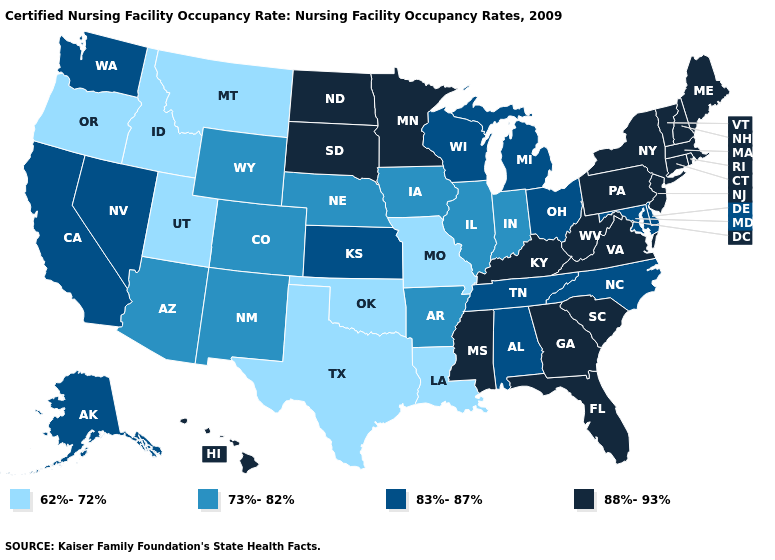Is the legend a continuous bar?
Answer briefly. No. Which states hav the highest value in the South?
Give a very brief answer. Florida, Georgia, Kentucky, Mississippi, South Carolina, Virginia, West Virginia. What is the highest value in the South ?
Answer briefly. 88%-93%. Does New Hampshire have the lowest value in the USA?
Quick response, please. No. What is the value of Missouri?
Be succinct. 62%-72%. Name the states that have a value in the range 83%-87%?
Answer briefly. Alabama, Alaska, California, Delaware, Kansas, Maryland, Michigan, Nevada, North Carolina, Ohio, Tennessee, Washington, Wisconsin. Does Delaware have a higher value than North Dakota?
Answer briefly. No. Name the states that have a value in the range 83%-87%?
Give a very brief answer. Alabama, Alaska, California, Delaware, Kansas, Maryland, Michigan, Nevada, North Carolina, Ohio, Tennessee, Washington, Wisconsin. Does the map have missing data?
Quick response, please. No. Name the states that have a value in the range 73%-82%?
Concise answer only. Arizona, Arkansas, Colorado, Illinois, Indiana, Iowa, Nebraska, New Mexico, Wyoming. Among the states that border California , does Nevada have the highest value?
Keep it brief. Yes. What is the value of Florida?
Keep it brief. 88%-93%. What is the value of Colorado?
Be succinct. 73%-82%. What is the value of Maryland?
Quick response, please. 83%-87%. Among the states that border Louisiana , which have the highest value?
Write a very short answer. Mississippi. 